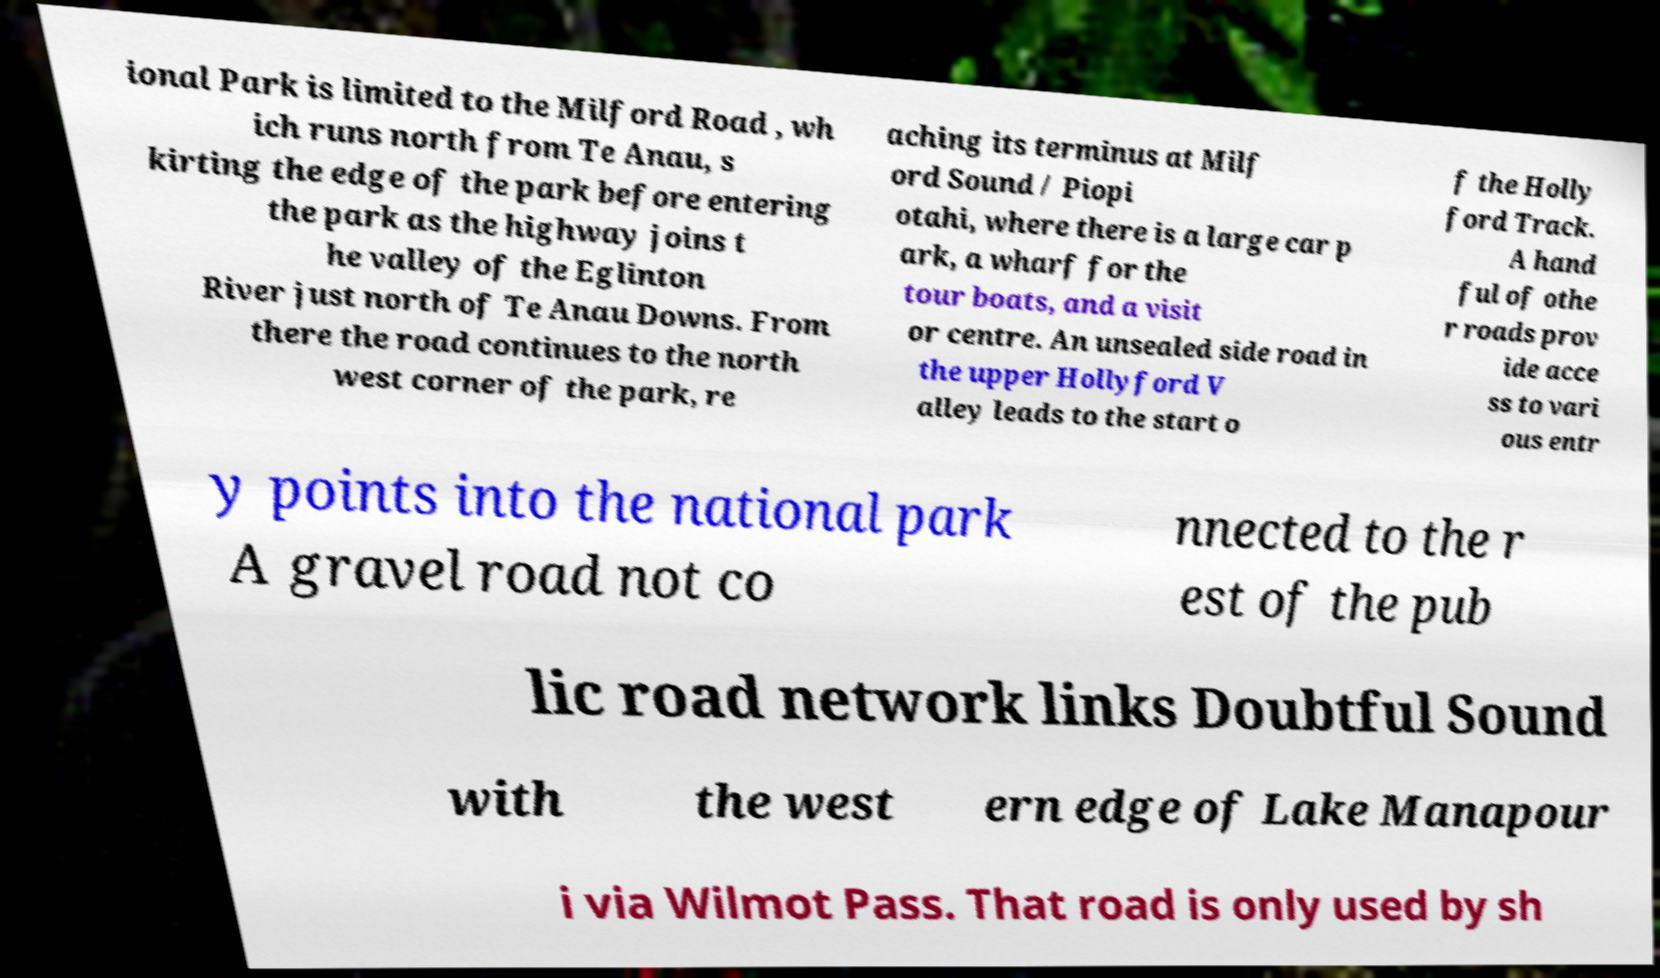Please read and relay the text visible in this image. What does it say? ional Park is limited to the Milford Road , wh ich runs north from Te Anau, s kirting the edge of the park before entering the park as the highway joins t he valley of the Eglinton River just north of Te Anau Downs. From there the road continues to the north west corner of the park, re aching its terminus at Milf ord Sound / Piopi otahi, where there is a large car p ark, a wharf for the tour boats, and a visit or centre. An unsealed side road in the upper Hollyford V alley leads to the start o f the Holly ford Track. A hand ful of othe r roads prov ide acce ss to vari ous entr y points into the national park A gravel road not co nnected to the r est of the pub lic road network links Doubtful Sound with the west ern edge of Lake Manapour i via Wilmot Pass. That road is only used by sh 